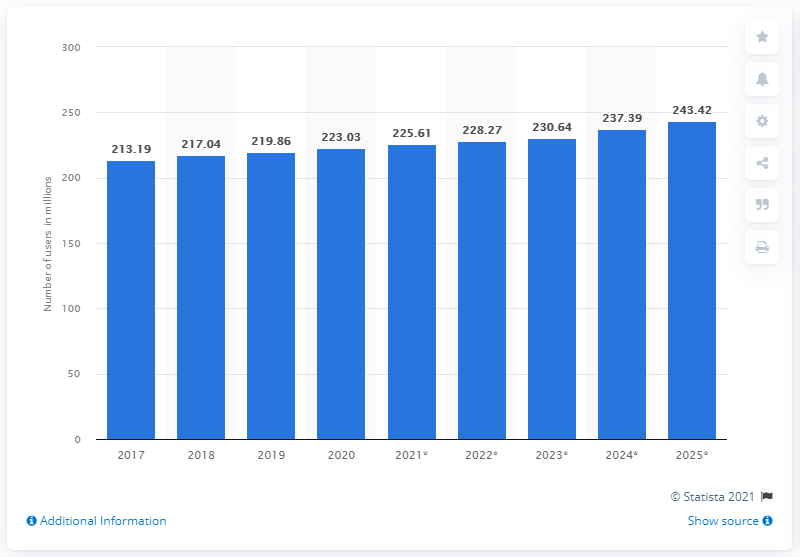Point out several critical features in this image. In the United States, the total number of social network users is projected to reach approximately 939.72 million from 2022 to 2025. In 2025, there were an estimated 243.42 million social network users in the United States. 